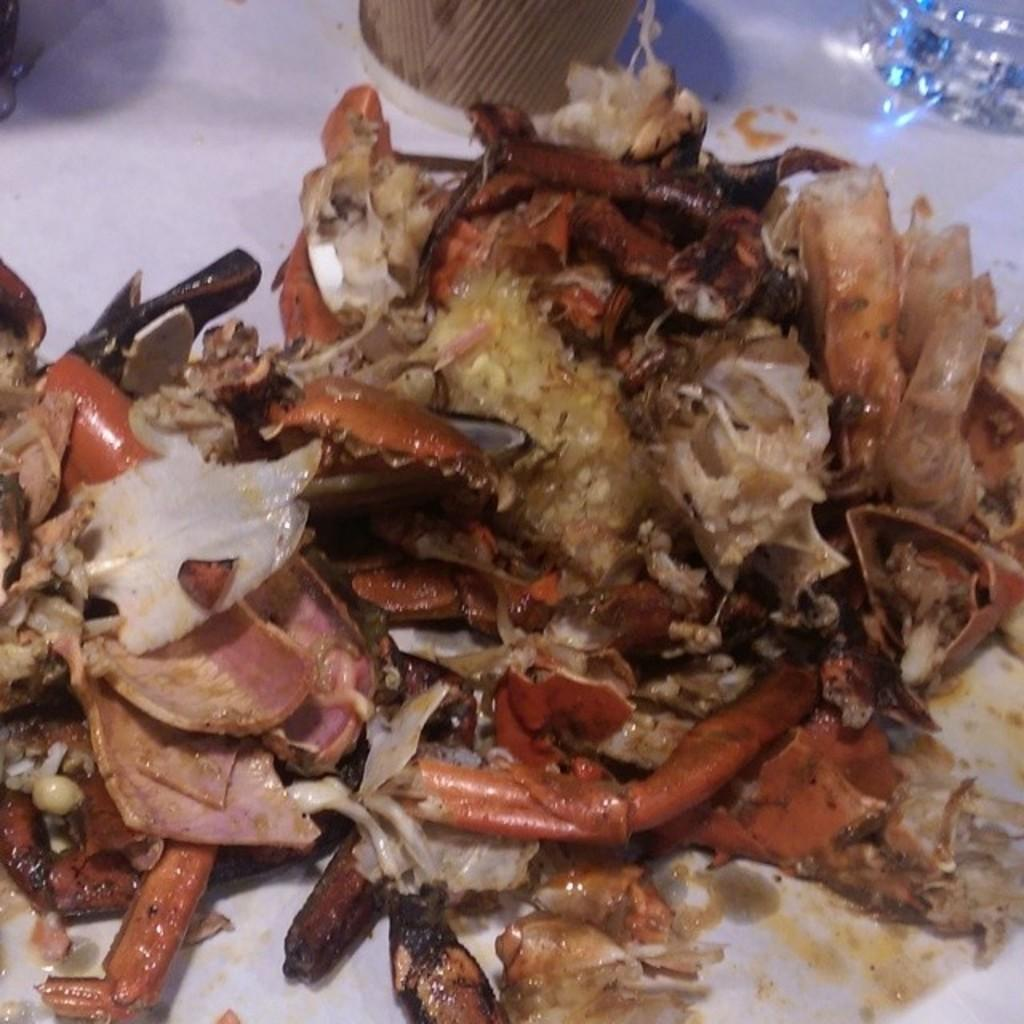What is on the plate that is visible in the image? There is food on a plate in the image. Where is the plate located in the image? The plate is placed on a table in the image. What else can be seen on the table in the image? There is a glass on the table in the image. How many pigs are playing basketball on the table in the image? There are no pigs or basketballs present in the image; it only features a plate of food and a glass on a table. 